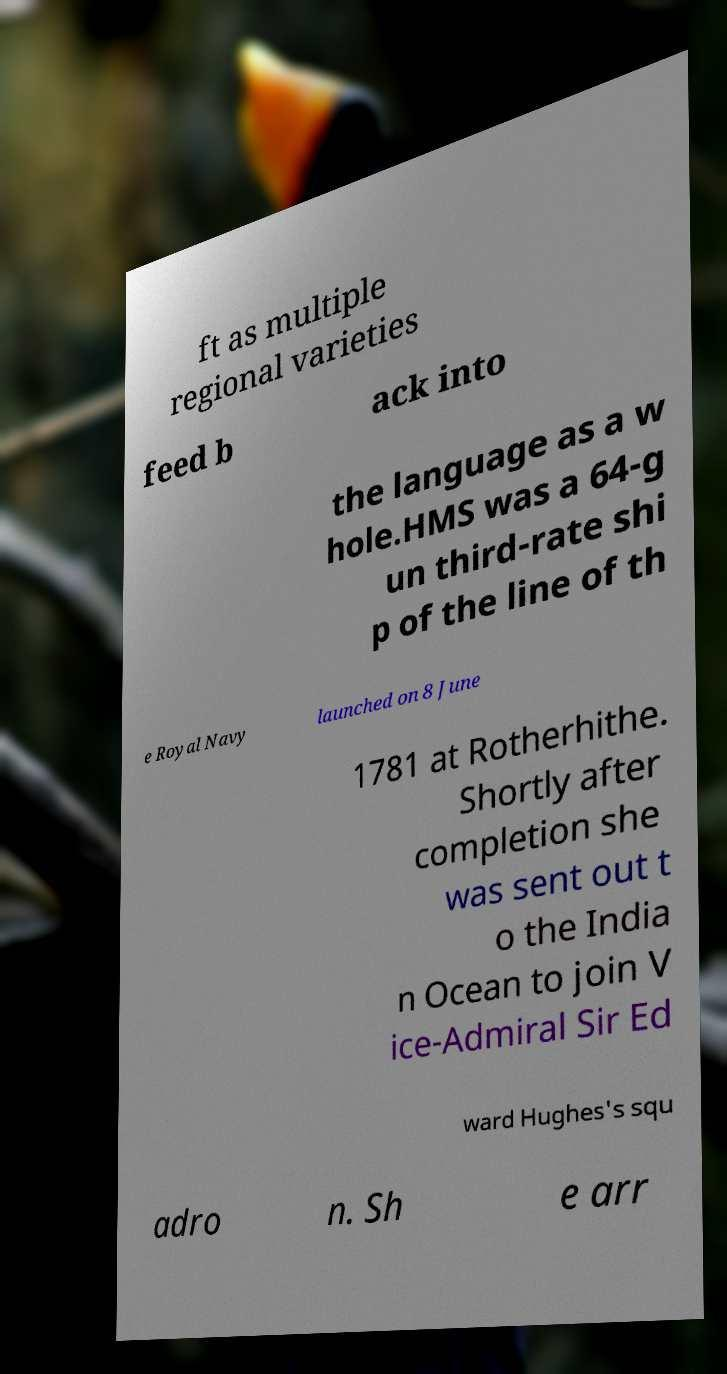For documentation purposes, I need the text within this image transcribed. Could you provide that? ft as multiple regional varieties feed b ack into the language as a w hole.HMS was a 64-g un third-rate shi p of the line of th e Royal Navy launched on 8 June 1781 at Rotherhithe. Shortly after completion she was sent out t o the India n Ocean to join V ice-Admiral Sir Ed ward Hughes's squ adro n. Sh e arr 